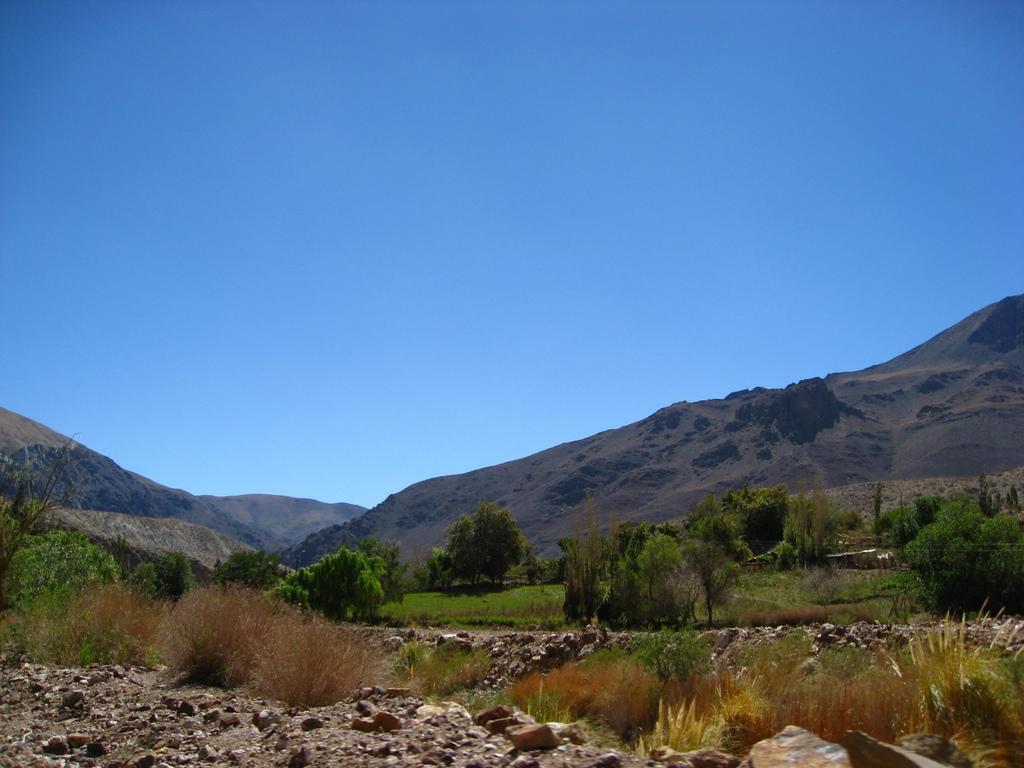Can you describe this image briefly? In this image we can see some stones, plants, trees and in the background of the image there are some mountains and clear sky. 